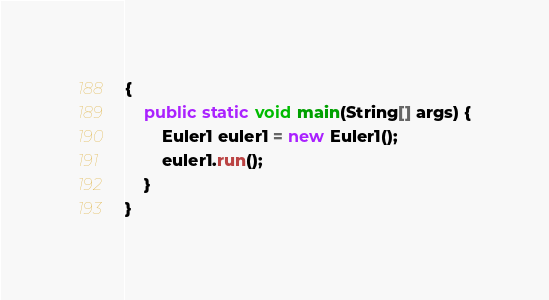Convert code to text. <code><loc_0><loc_0><loc_500><loc_500><_Java_>{
    public static void main(String[] args) {
		Euler1 euler1 = new Euler1();
		euler1.run();
	}
}
</code> 